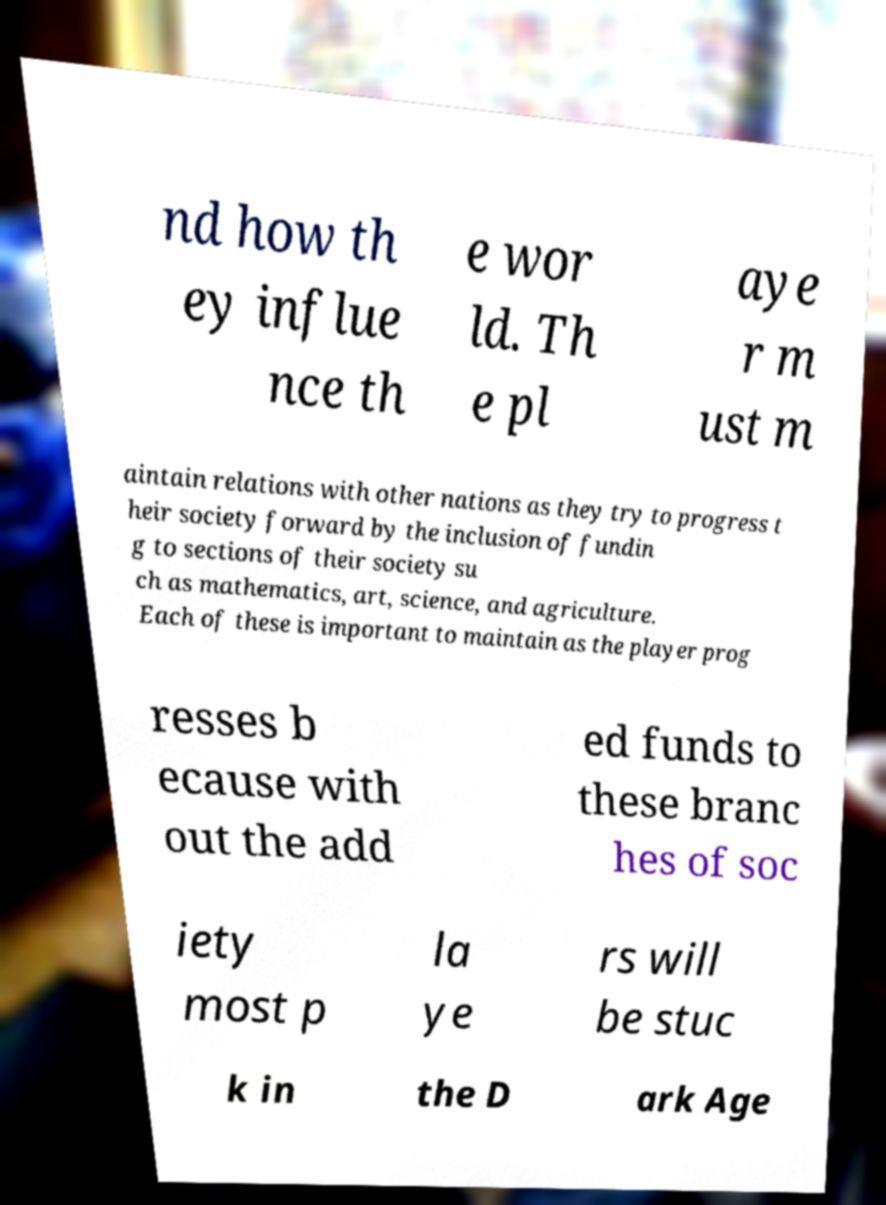Can you accurately transcribe the text from the provided image for me? nd how th ey influe nce th e wor ld. Th e pl aye r m ust m aintain relations with other nations as they try to progress t heir society forward by the inclusion of fundin g to sections of their society su ch as mathematics, art, science, and agriculture. Each of these is important to maintain as the player prog resses b ecause with out the add ed funds to these branc hes of soc iety most p la ye rs will be stuc k in the D ark Age 